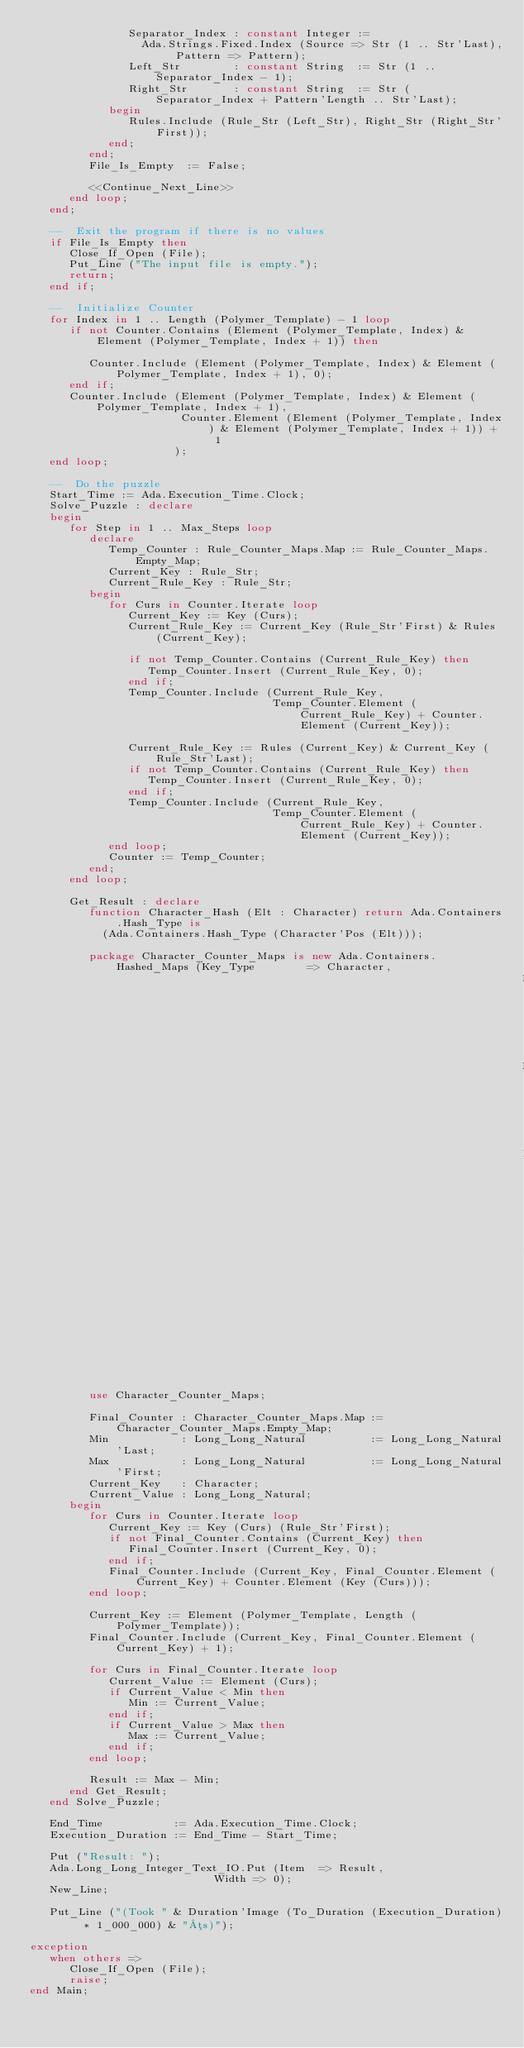Convert code to text. <code><loc_0><loc_0><loc_500><loc_500><_Ada_>               Separator_Index : constant Integer :=
                 Ada.Strings.Fixed.Index (Source => Str (1 .. Str'Last), Pattern => Pattern);
               Left_Str        : constant String  := Str (1 .. Separator_Index - 1);
               Right_Str       : constant String  := Str (Separator_Index + Pattern'Length .. Str'Last);
            begin
               Rules.Include (Rule_Str (Left_Str), Right_Str (Right_Str'First));
            end;
         end;
         File_Is_Empty  := False;

         <<Continue_Next_Line>>
      end loop;
   end;

   --  Exit the program if there is no values
   if File_Is_Empty then
      Close_If_Open (File);
      Put_Line ("The input file is empty.");
      return;
   end if;

   --  Initialize Counter
   for Index in 1 .. Length (Polymer_Template) - 1 loop
      if not Counter.Contains (Element (Polymer_Template, Index) & Element (Polymer_Template, Index + 1)) then

         Counter.Include (Element (Polymer_Template, Index) & Element (Polymer_Template, Index + 1), 0);
      end if;
      Counter.Include (Element (Polymer_Template, Index) & Element (Polymer_Template, Index + 1),
                       Counter.Element (Element (Polymer_Template, Index) & Element (Polymer_Template, Index + 1)) + 1
                      );
   end loop;

   --  Do the puzzle
   Start_Time := Ada.Execution_Time.Clock;
   Solve_Puzzle : declare
   begin
      for Step in 1 .. Max_Steps loop
         declare
            Temp_Counter : Rule_Counter_Maps.Map := Rule_Counter_Maps.Empty_Map;
            Current_Key : Rule_Str;
            Current_Rule_Key : Rule_Str;
         begin
            for Curs in Counter.Iterate loop
               Current_Key := Key (Curs);
               Current_Rule_Key := Current_Key (Rule_Str'First) & Rules (Current_Key);

               if not Temp_Counter.Contains (Current_Rule_Key) then
                  Temp_Counter.Insert (Current_Rule_Key, 0);
               end if;
               Temp_Counter.Include (Current_Rule_Key,
                                     Temp_Counter.Element (Current_Rule_Key) + Counter.Element (Current_Key));

               Current_Rule_Key := Rules (Current_Key) & Current_Key (Rule_Str'Last);
               if not Temp_Counter.Contains (Current_Rule_Key) then
                  Temp_Counter.Insert (Current_Rule_Key, 0);
               end if;
               Temp_Counter.Include (Current_Rule_Key,
                                     Temp_Counter.Element (Current_Rule_Key) + Counter.Element (Current_Key));
            end loop;
            Counter := Temp_Counter;
         end;
      end loop;

      Get_Result : declare
         function Character_Hash (Elt : Character) return Ada.Containers.Hash_Type is
           (Ada.Containers.Hash_Type (Character'Pos (Elt)));

         package Character_Counter_Maps is new Ada.Containers.Hashed_Maps (Key_Type        => Character,
                                                                           Element_Type    => Long_Long_Natural,
                                                                           Hash            => Character_Hash,
                                                                           Equivalent_Keys => "=",
                                                                           "="             => "=");
         use Character_Counter_Maps;

         Final_Counter : Character_Counter_Maps.Map := Character_Counter_Maps.Empty_Map;
         Min           : Long_Long_Natural          := Long_Long_Natural'Last;
         Max           : Long_Long_Natural          := Long_Long_Natural'First;
         Current_Key   : Character;
         Current_Value : Long_Long_Natural;
      begin
         for Curs in Counter.Iterate loop
            Current_Key := Key (Curs) (Rule_Str'First);
            if not Final_Counter.Contains (Current_Key) then
               Final_Counter.Insert (Current_Key, 0);
            end if;
            Final_Counter.Include (Current_Key, Final_Counter.Element (Current_Key) + Counter.Element (Key (Curs)));
         end loop;

         Current_Key := Element (Polymer_Template, Length (Polymer_Template));
         Final_Counter.Include (Current_Key, Final_Counter.Element (Current_Key) + 1);

         for Curs in Final_Counter.Iterate loop
            Current_Value := Element (Curs);
            if Current_Value < Min then
               Min := Current_Value;
            end if;
            if Current_Value > Max then
               Max := Current_Value;
            end if;
         end loop;

         Result := Max - Min;
      end Get_Result;
   end Solve_Puzzle;

   End_Time           := Ada.Execution_Time.Clock;
   Execution_Duration := End_Time - Start_Time;

   Put ("Result: ");
   Ada.Long_Long_Integer_Text_IO.Put (Item  => Result,
                            Width => 0);
   New_Line;

   Put_Line ("(Took " & Duration'Image (To_Duration (Execution_Duration) * 1_000_000) & "µs)");

exception
   when others =>
      Close_If_Open (File);
      raise;
end Main;
</code> 